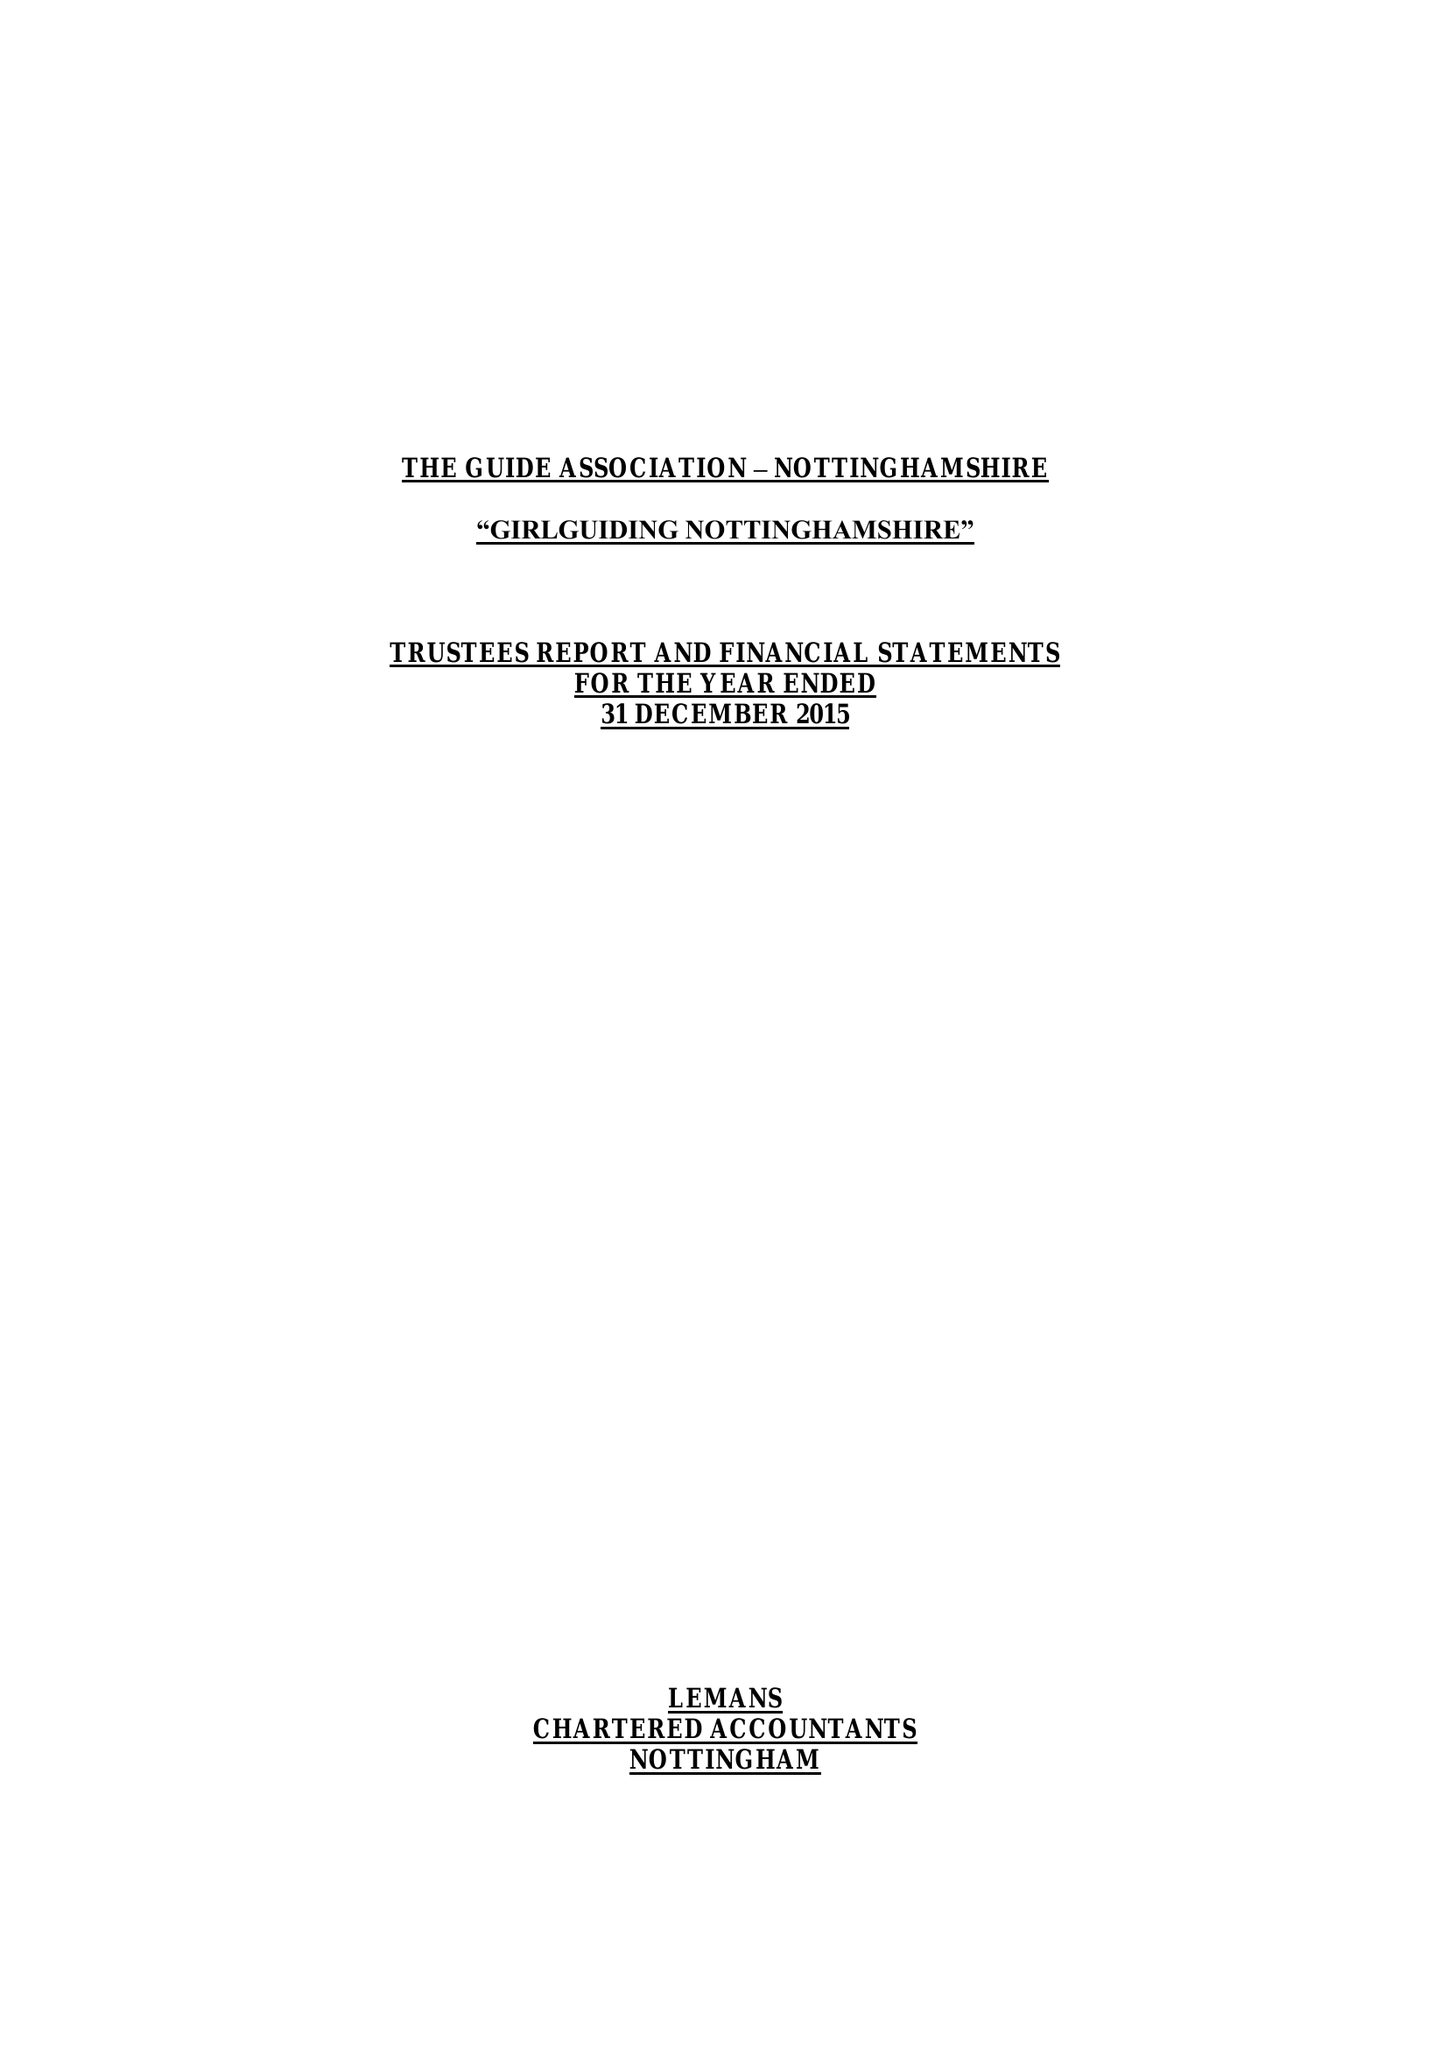What is the value for the address__street_line?
Answer the question using a single word or phrase. 16-18 BURTON ROAD 